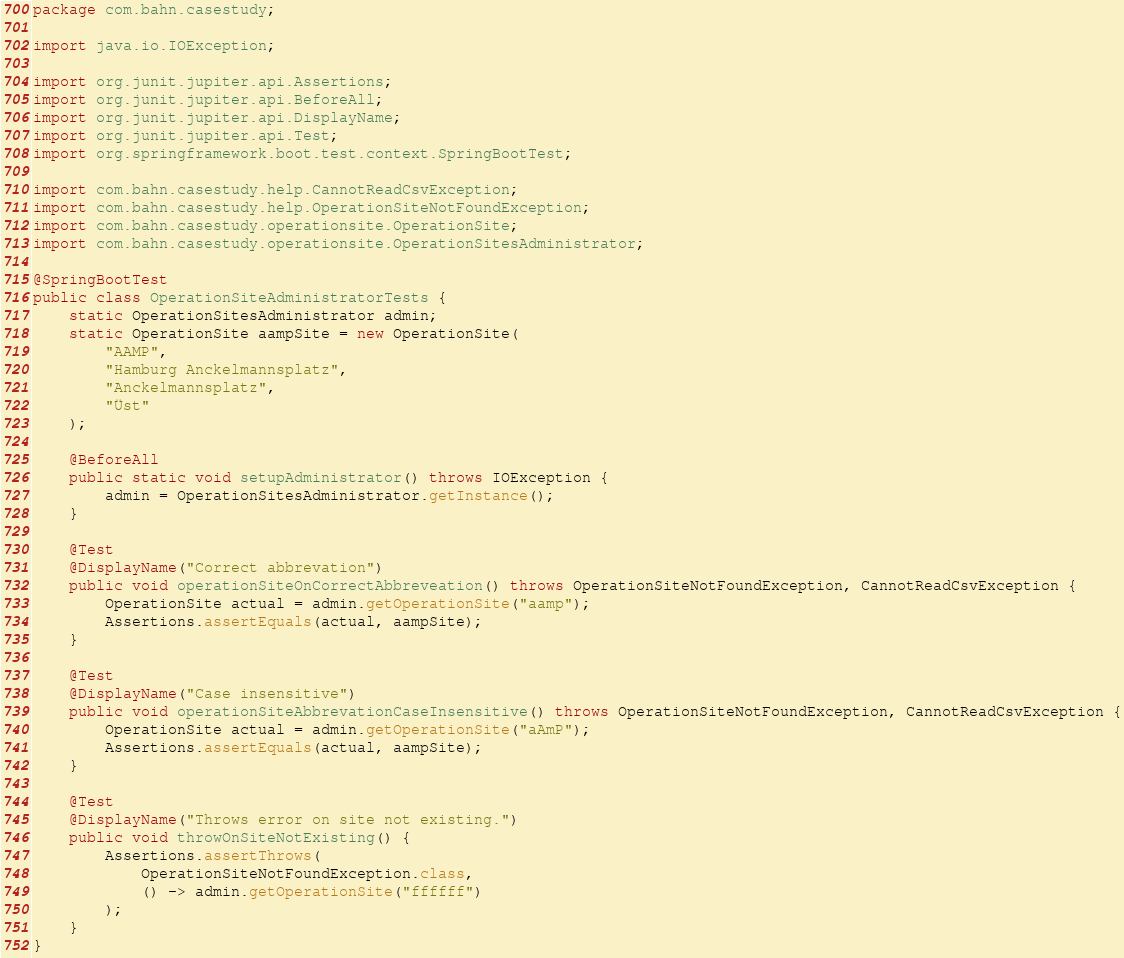<code> <loc_0><loc_0><loc_500><loc_500><_Java_>package com.bahn.casestudy;

import java.io.IOException;

import org.junit.jupiter.api.Assertions;
import org.junit.jupiter.api.BeforeAll;
import org.junit.jupiter.api.DisplayName;
import org.junit.jupiter.api.Test;
import org.springframework.boot.test.context.SpringBootTest;

import com.bahn.casestudy.help.CannotReadCsvException;
import com.bahn.casestudy.help.OperationSiteNotFoundException;
import com.bahn.casestudy.operationsite.OperationSite;
import com.bahn.casestudy.operationsite.OperationSitesAdministrator;

@SpringBootTest
public class OperationSiteAdministratorTests {
	static OperationSitesAdministrator admin;
	static OperationSite aampSite = new OperationSite(
		"AAMP",
		"Hamburg Anckelmannsplatz",
		"Anckelmannsplatz",
		"Üst"
	);
	
	@BeforeAll
	public static void setupAdministrator() throws IOException {
		admin = OperationSitesAdministrator.getInstance();
	}
		
	@Test
	@DisplayName("Correct abbrevation")
	public void operationSiteOnCorrectAbbreveation() throws OperationSiteNotFoundException, CannotReadCsvException {
		OperationSite actual = admin.getOperationSite("aamp");		
		Assertions.assertEquals(actual, aampSite);
	}
		
	@Test
	@DisplayName("Case insensitive")
	public void operationSiteAbbrevationCaseInsensitive() throws OperationSiteNotFoundException, CannotReadCsvException {
		OperationSite actual = admin.getOperationSite("aAmP");
		Assertions.assertEquals(actual, aampSite);
	}
	
	@Test
	@DisplayName("Throws error on site not existing.")
	public void throwOnSiteNotExisting() {
		Assertions.assertThrows(
			OperationSiteNotFoundException.class, 
			() -> admin.getOperationSite("ffffff")
		);
	}
}
</code> 